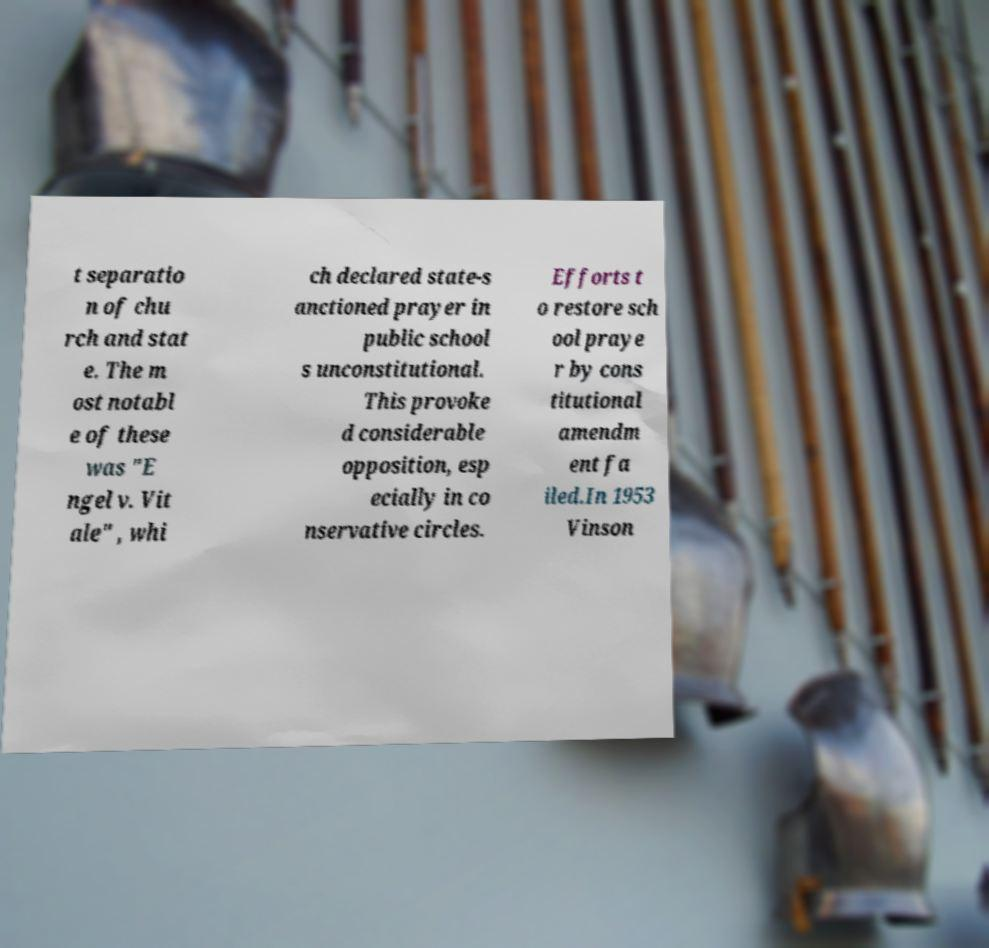Could you assist in decoding the text presented in this image and type it out clearly? t separatio n of chu rch and stat e. The m ost notabl e of these was "E ngel v. Vit ale" , whi ch declared state-s anctioned prayer in public school s unconstitutional. This provoke d considerable opposition, esp ecially in co nservative circles. Efforts t o restore sch ool praye r by cons titutional amendm ent fa iled.In 1953 Vinson 